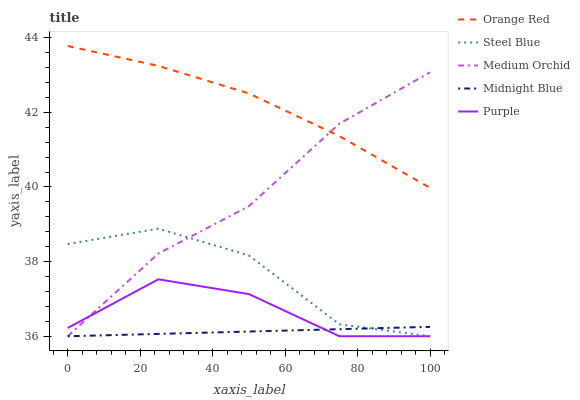Does Midnight Blue have the minimum area under the curve?
Answer yes or no. Yes. Does Orange Red have the maximum area under the curve?
Answer yes or no. Yes. Does Medium Orchid have the minimum area under the curve?
Answer yes or no. No. Does Medium Orchid have the maximum area under the curve?
Answer yes or no. No. Is Midnight Blue the smoothest?
Answer yes or no. Yes. Is Steel Blue the roughest?
Answer yes or no. Yes. Is Medium Orchid the smoothest?
Answer yes or no. No. Is Medium Orchid the roughest?
Answer yes or no. No. Does Purple have the lowest value?
Answer yes or no. Yes. Does Orange Red have the lowest value?
Answer yes or no. No. Does Orange Red have the highest value?
Answer yes or no. Yes. Does Medium Orchid have the highest value?
Answer yes or no. No. Is Steel Blue less than Orange Red?
Answer yes or no. Yes. Is Orange Red greater than Purple?
Answer yes or no. Yes. Does Midnight Blue intersect Purple?
Answer yes or no. Yes. Is Midnight Blue less than Purple?
Answer yes or no. No. Is Midnight Blue greater than Purple?
Answer yes or no. No. Does Steel Blue intersect Orange Red?
Answer yes or no. No. 